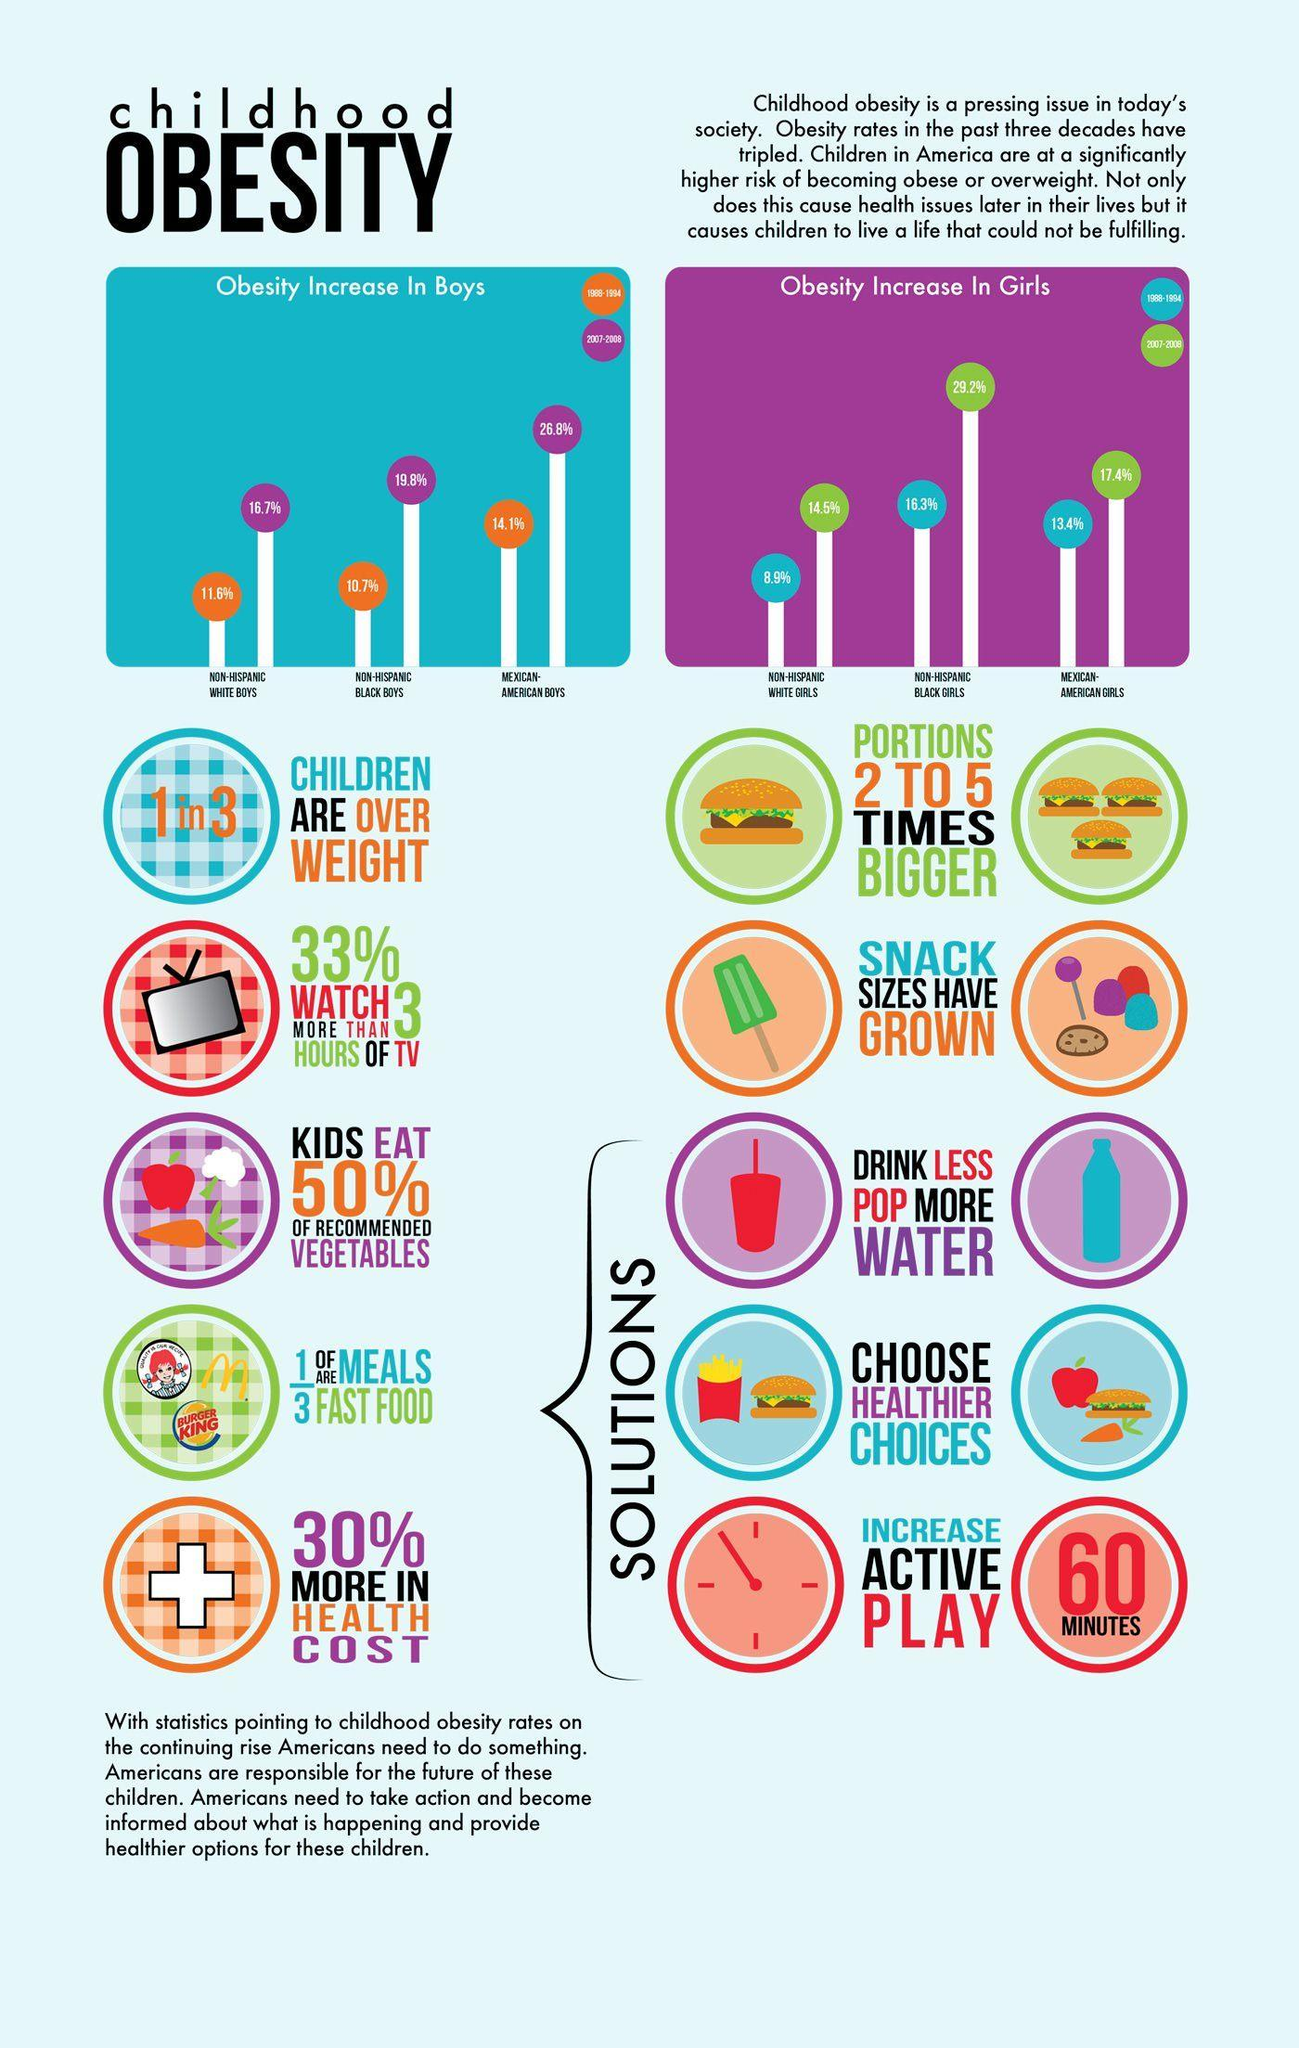List a handful of essential elements in this visual. In 2007-2008, there was a 26.8% increase in obesity among Mexican American boys, as observed. During the years 2007-2008, there was a significant increase in the prevalence of obesity among non-Hispanic black girls in America, with a percentage increase of 29.2%. The percentage increase of obesity in non-Hispanic black boys in America during the period of 2007-2008 was 19.8%. During the period of 1988-1994, there was a 14.1% increase in the prevalence of obesity among Mexican-American boys. During the time period of 1988-1994, an increase of 16.3% in obesity was observed among Non-Hispanic black girls. 